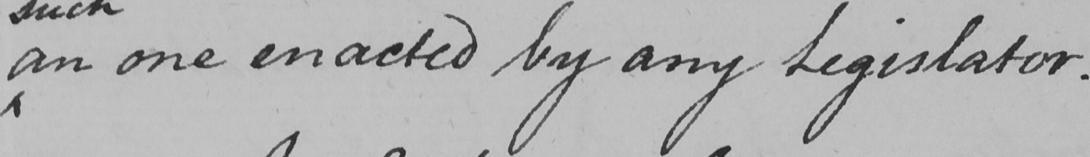What text is written in this handwritten line? an one enacted by any Legislator . 